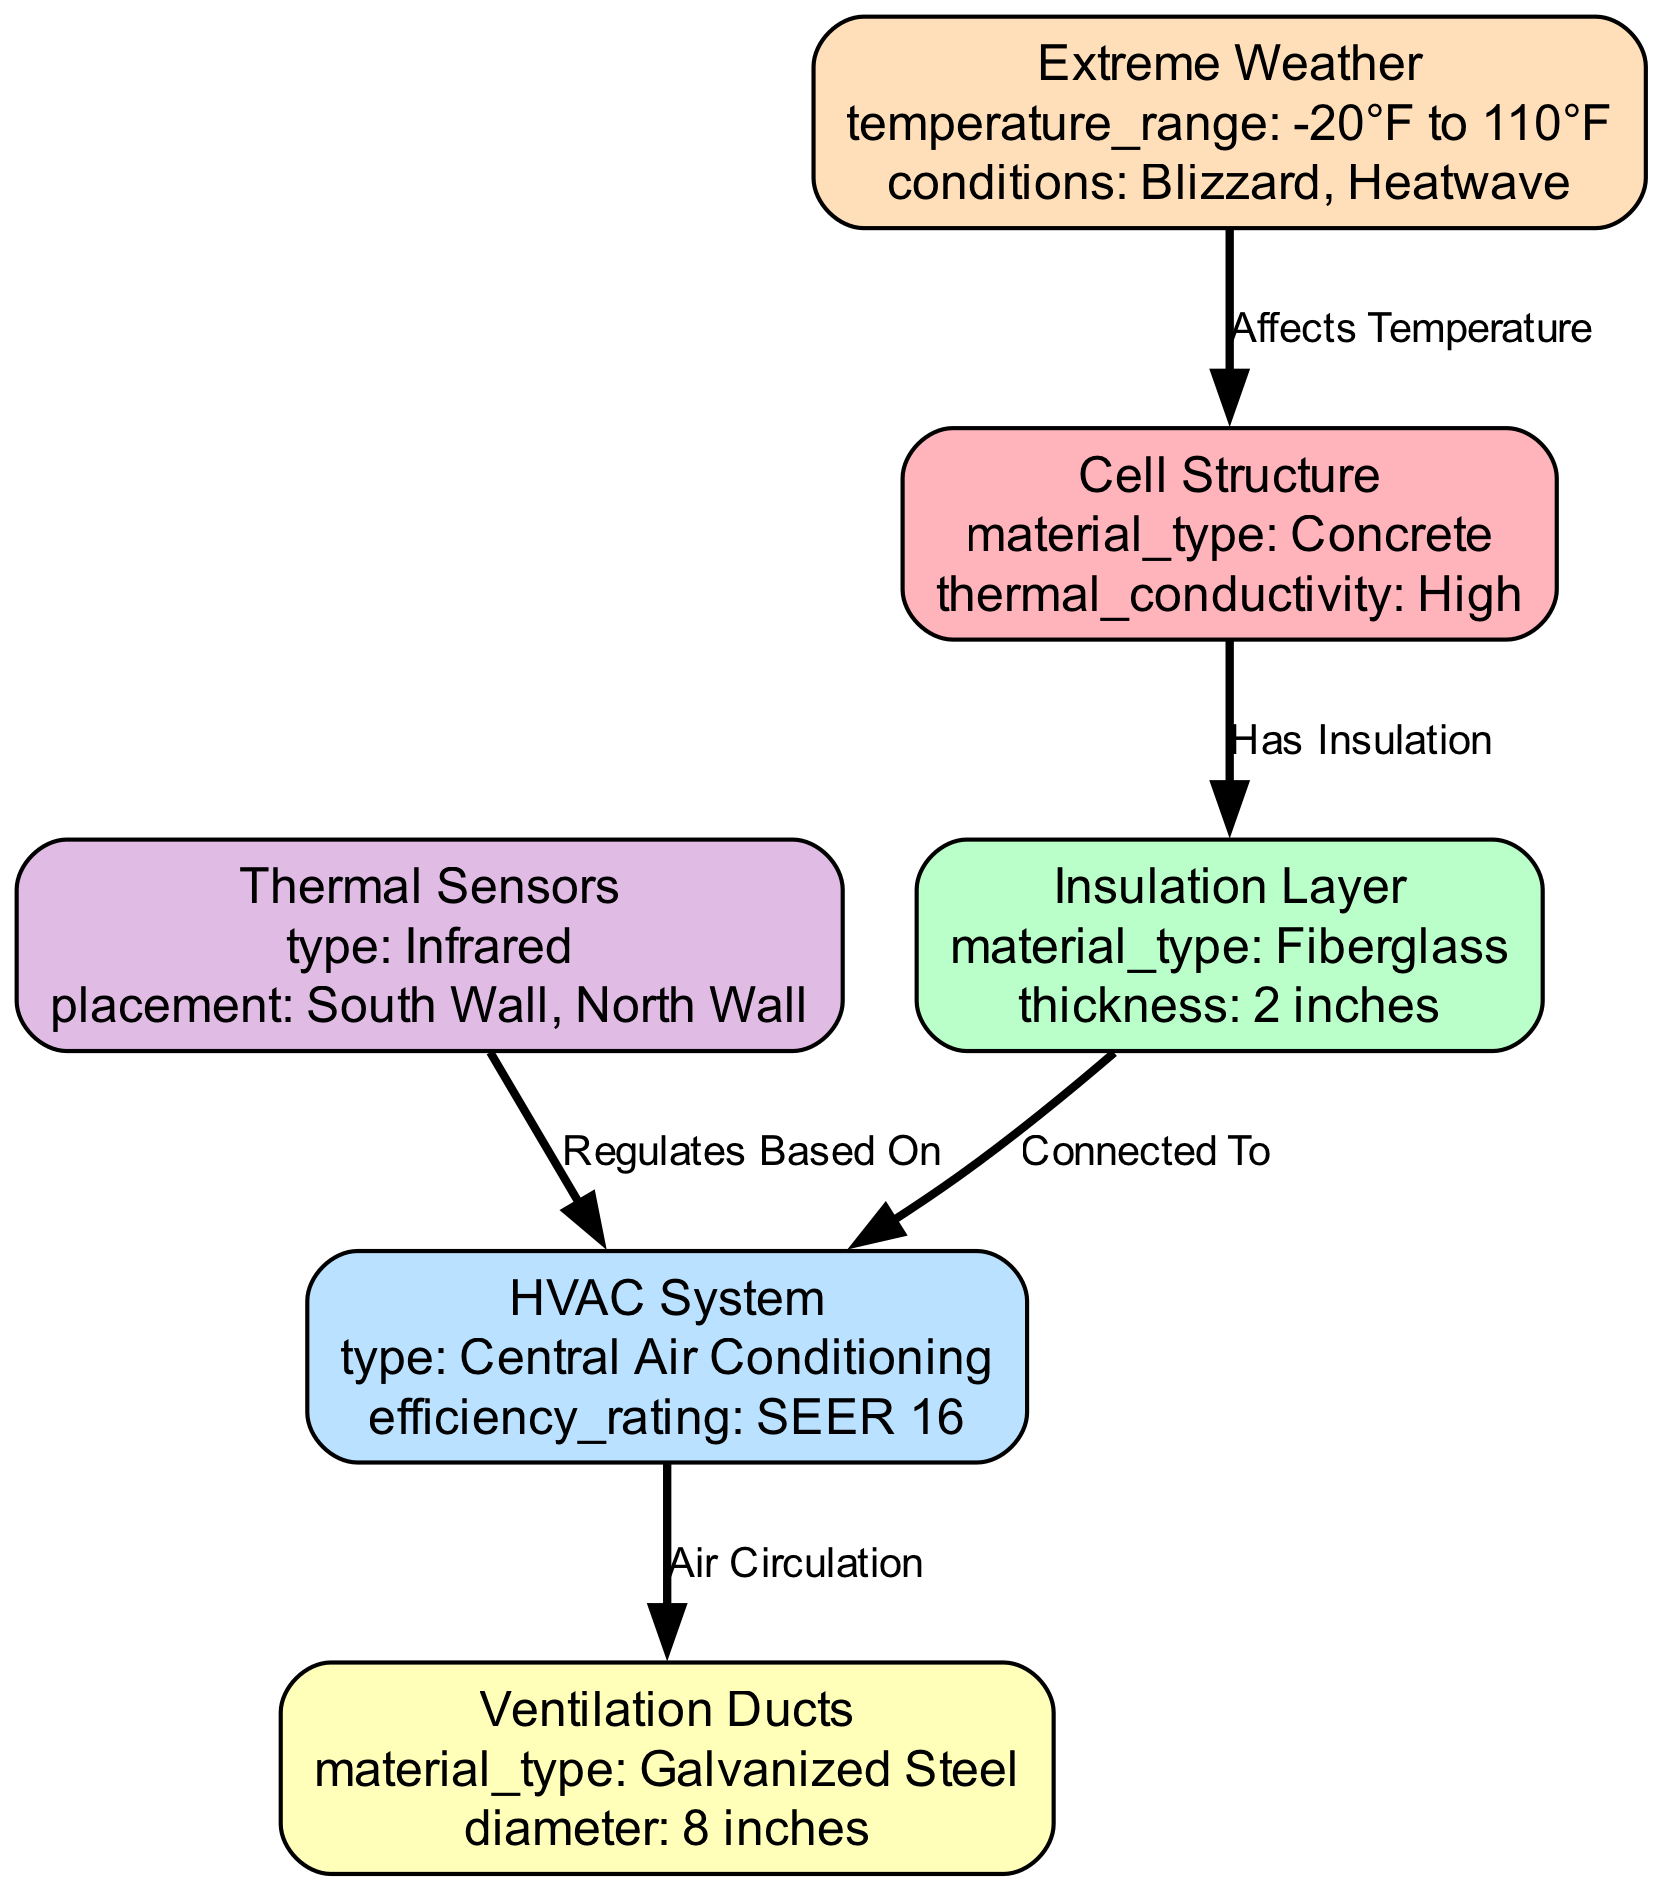What is the material type of the cell structure? The cell structure node specifies that its material type is concrete, which is explicitly mentioned in its properties.
Answer: Concrete How many edges are present in the diagram? The diagram includes five edges that connect various nodes, which can be counted by reviewing the edges section in the data structure.
Answer: 5 What is the thickness of the insulation layer? The insulation layer node states that its thickness is 2 inches, which is detailed in its properties section.
Answer: 2 inches What type of HVAC system is mentioned in the diagram? The HVAC system node identifies itself as a central air conditioning type within its properties, providing a specific description of the system used.
Answer: Central Air Conditioning How does extreme weather affect the temperature? Extreme weather, indicated in the diagram, is labeled to affect the temperature of the cell structure, pointing to the relationship between these two nodes.
Answer: Affects Temperature What regulates the HVAC system according to the diagram? The thermal sensors are noted to regulate the HVAC system based on their placement, which is shown as a direct connection between these two nodes.
Answer: Regulates Based On Which material is used for the ventilation ducts? The ventilation ducts node specifies that they are made of galvanized steel, clearly stated in their properties.
Answer: Galvanized Steel What is the diameter of the ventilation ducts? The properties of the ventilation ducts point out that their diameter is 8 inches, providing this specific measurable detail.
Answer: 8 inches What temperature range is defined for extreme weather conditions? The extreme weather node shows a temperature range from -20°F to 110°F, which describes the conditions that the cell may experience.
Answer: -20°F to 110°F 